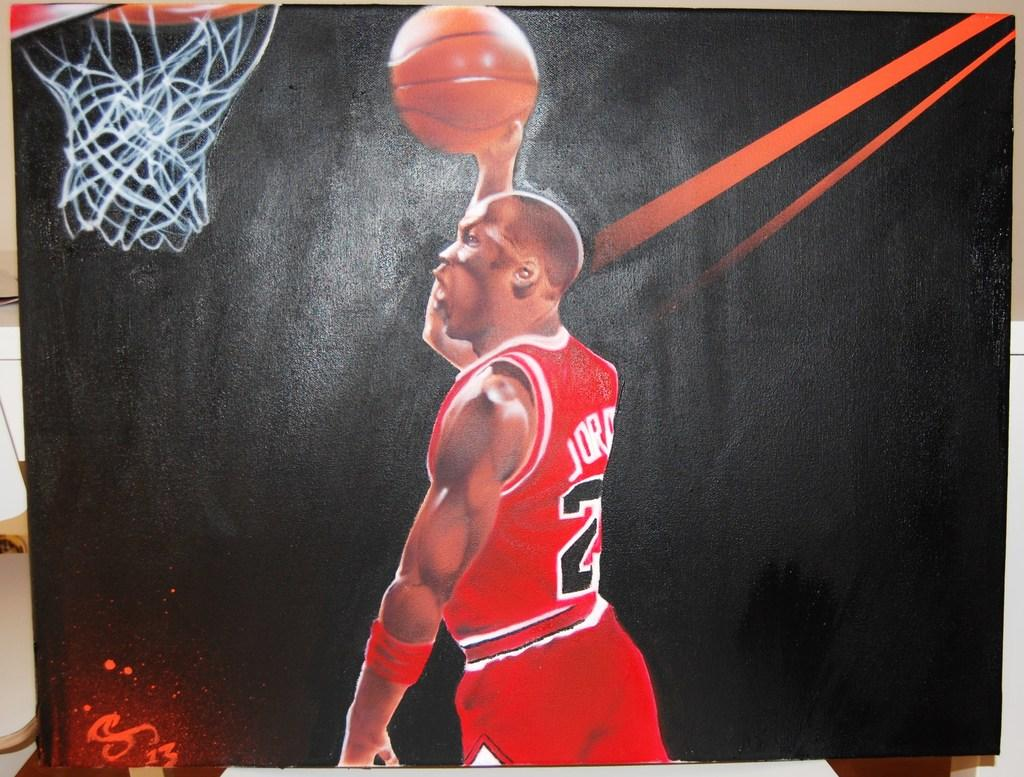Who or what is present in the image? There is a person in the image. What is the person holding in their hand? The person is holding a basketball in their hand. What is the purpose of the net and ring in the image? The net and ring are likely part of a basketball hoop. What is written on the blackboard in the image? There are letters on a blackboard in the image. What other objects can be seen in the image? There are other objects visible in the image, but their specific details are not mentioned in the provided facts. What type of thrill can be seen on the ghost's face in the image? There is no ghost present in the image, and therefore no facial expressions or thrill can be observed. 